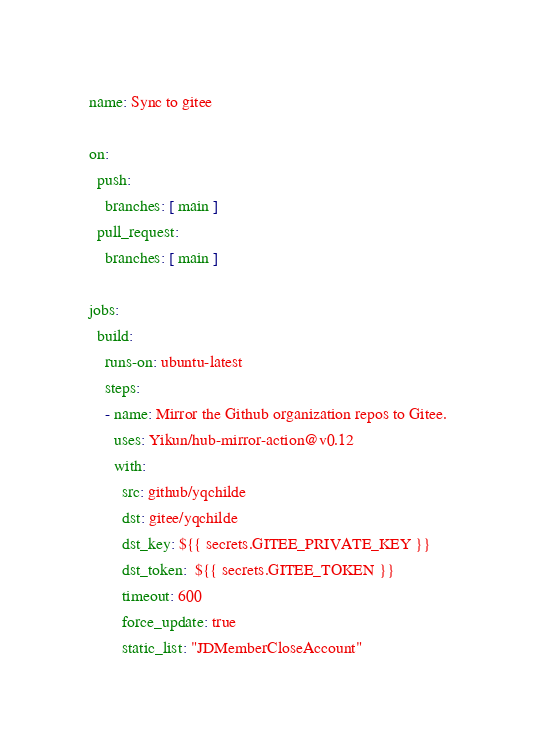Convert code to text. <code><loc_0><loc_0><loc_500><loc_500><_YAML_>name: Sync to gitee

on:
  push:
    branches: [ main ]
  pull_request:
    branches: [ main ]

jobs:
  build:
    runs-on: ubuntu-latest
    steps:
    - name: Mirror the Github organization repos to Gitee.
      uses: Yikun/hub-mirror-action@v0.12
      with:
        src: github/yqchilde
        dst: gitee/yqchilde
        dst_key: ${{ secrets.GITEE_PRIVATE_KEY }}
        dst_token:  ${{ secrets.GITEE_TOKEN }}
        timeout: 600
        force_update: true
        static_list: "JDMemberCloseAccount"</code> 